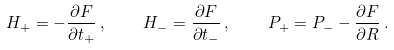Convert formula to latex. <formula><loc_0><loc_0><loc_500><loc_500>H _ { + } = - \frac { \partial F } { \partial t _ { + } } \, , \quad H _ { - } = \frac { \partial F } { \partial t _ { - } } \, , \quad P _ { + } = P _ { - } - \frac { \partial F } { \partial R } \, .</formula> 